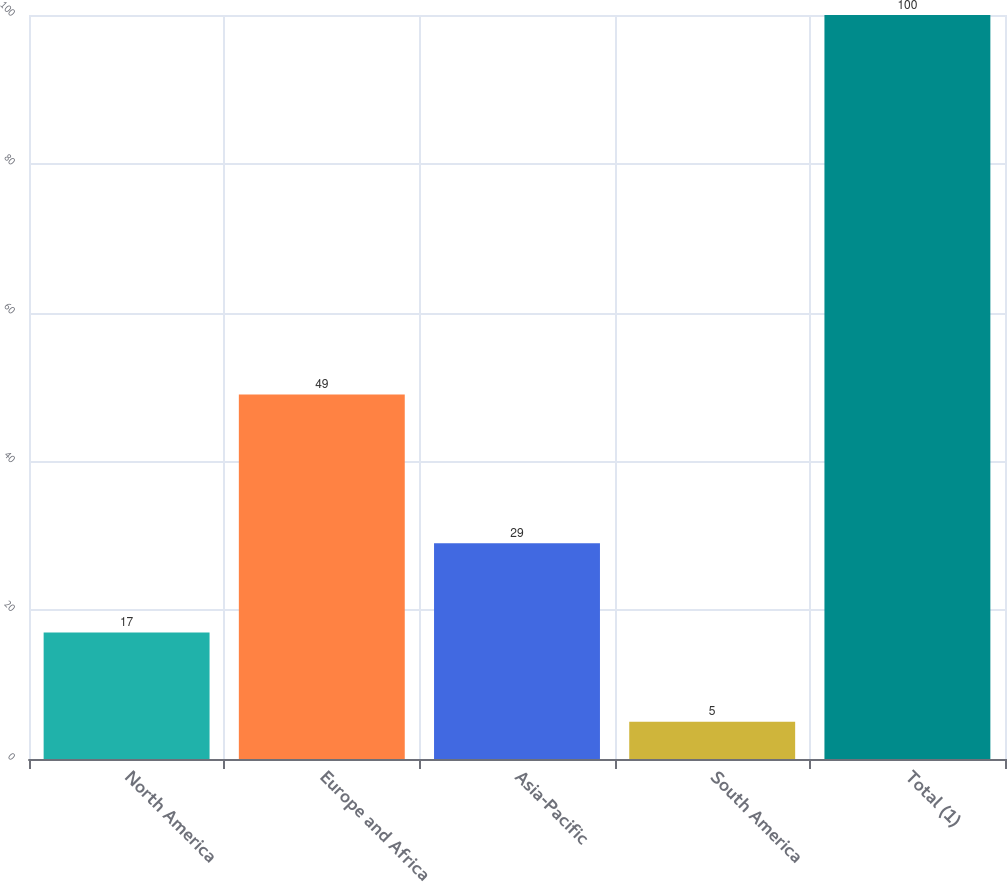<chart> <loc_0><loc_0><loc_500><loc_500><bar_chart><fcel>North America<fcel>Europe and Africa<fcel>Asia-Pacific<fcel>South America<fcel>Total (1)<nl><fcel>17<fcel>49<fcel>29<fcel>5<fcel>100<nl></chart> 